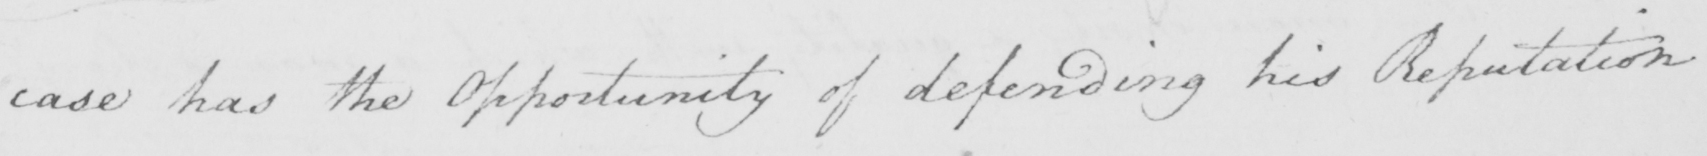Can you read and transcribe this handwriting? case has the Opportunity of defending his Reputation 